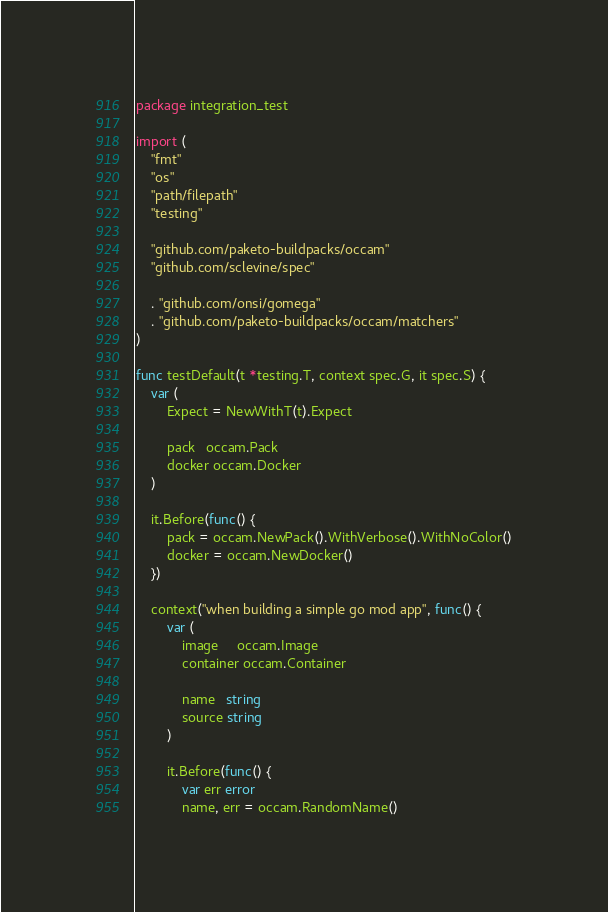<code> <loc_0><loc_0><loc_500><loc_500><_Go_>package integration_test

import (
	"fmt"
	"os"
	"path/filepath"
	"testing"

	"github.com/paketo-buildpacks/occam"
	"github.com/sclevine/spec"

	. "github.com/onsi/gomega"
	. "github.com/paketo-buildpacks/occam/matchers"
)

func testDefault(t *testing.T, context spec.G, it spec.S) {
	var (
		Expect = NewWithT(t).Expect

		pack   occam.Pack
		docker occam.Docker
	)

	it.Before(func() {
		pack = occam.NewPack().WithVerbose().WithNoColor()
		docker = occam.NewDocker()
	})

	context("when building a simple go mod app", func() {
		var (
			image     occam.Image
			container occam.Container

			name   string
			source string
		)

		it.Before(func() {
			var err error
			name, err = occam.RandomName()</code> 